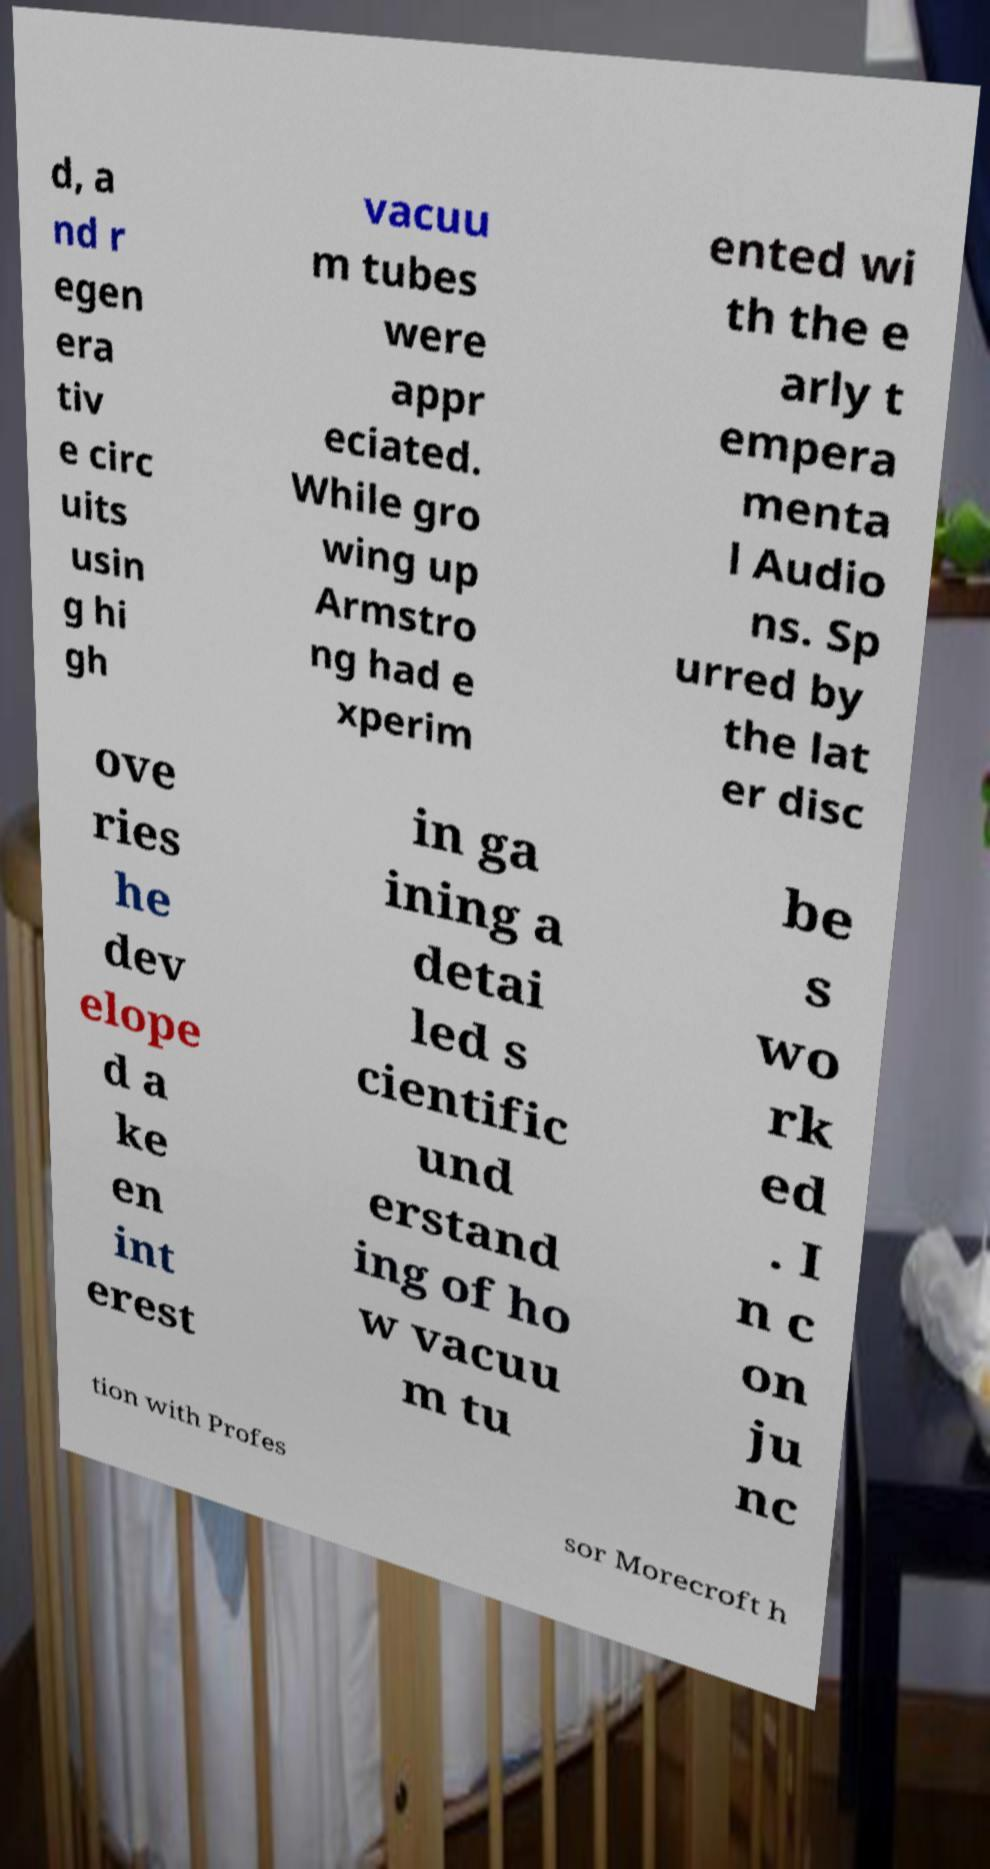Could you extract and type out the text from this image? d, a nd r egen era tiv e circ uits usin g hi gh vacuu m tubes were appr eciated. While gro wing up Armstro ng had e xperim ented wi th the e arly t empera menta l Audio ns. Sp urred by the lat er disc ove ries he dev elope d a ke en int erest in ga ining a detai led s cientific und erstand ing of ho w vacuu m tu be s wo rk ed . I n c on ju nc tion with Profes sor Morecroft h 